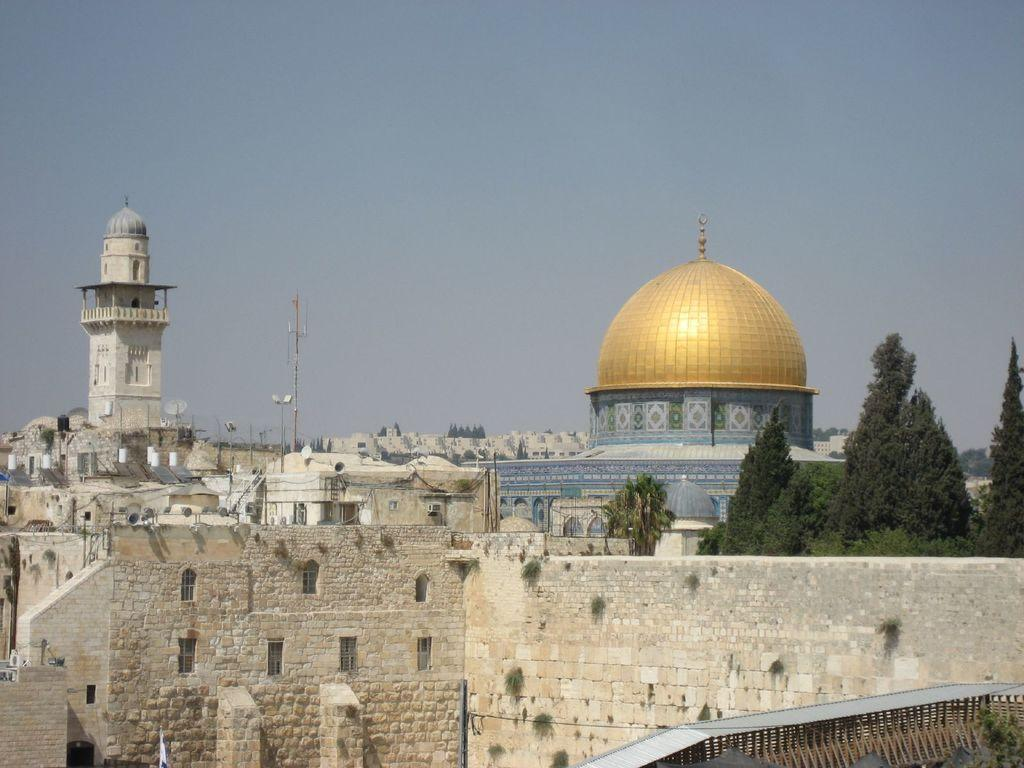What object is located in the middle of the image? There is a mask in the middle of the image. What type of vegetation is on the right side of the image? There are trees on the right side of the image. What type of structure is at the bottom of the image? There is a stone wall at the bottom of the image. What is visible at the top of the image? The sky is visible at the top of the image. How many wings can be seen on the mask in the image? There are no wings present on the mask in the image. What type of egg is visible in the image? There are no eggs present in the image. 